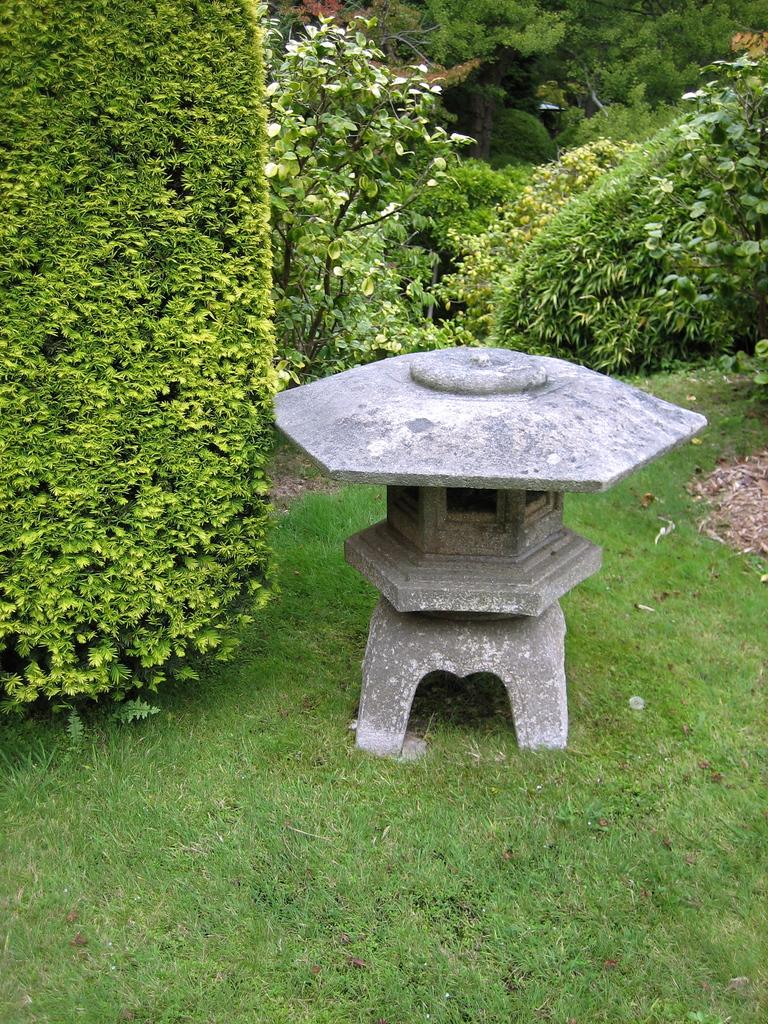What type of vegetation is in the foreground of the image? There is grass in the foreground of the image. What can be seen in the middle of the image? There are trees and dry leaves present in the middle of the image, along with a stone object. What type of vegetation is in the background of the image? There are trees and plants in the background of the image. What type of cushion is being used for dinner in the image? There is no dinner or cushion present in the image. How does the stone object show respect in the image? The stone object does not show respect in the image; it is simply a stationary object in the middle of the image. 